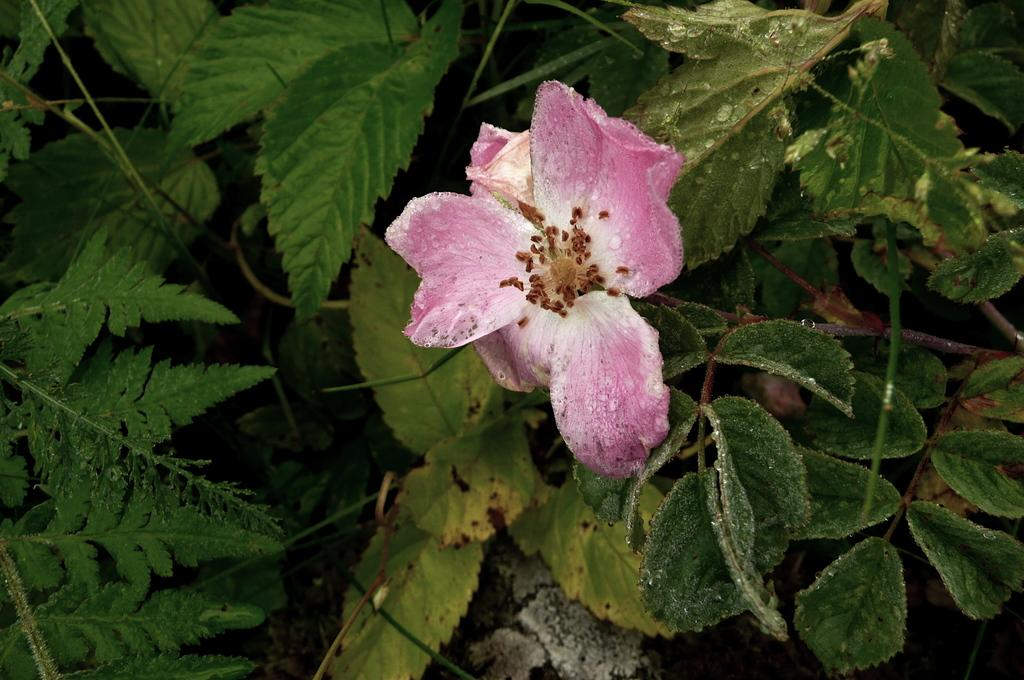What type of plant is in the image? There is a plant in the image. What color are the leaves of the plant? The plant has green leaves. What additional feature can be seen on the plant? The plant has a pink flower with petals. Reasoning: Let's think step by step by step in order to produce the conversation. We start by identifying the main subject in the image, which is the plant. Then, we expand the conversation to include details about the plant's leaves and any additional features, such as the flower. Each question is designed to elicit a specific detail about the image that is known from the provided facts. Absurd Question/Answer: What time of day is the plant being attacked by a stove in the image? There is no stove present in the image, and the plant is not being attacked. 